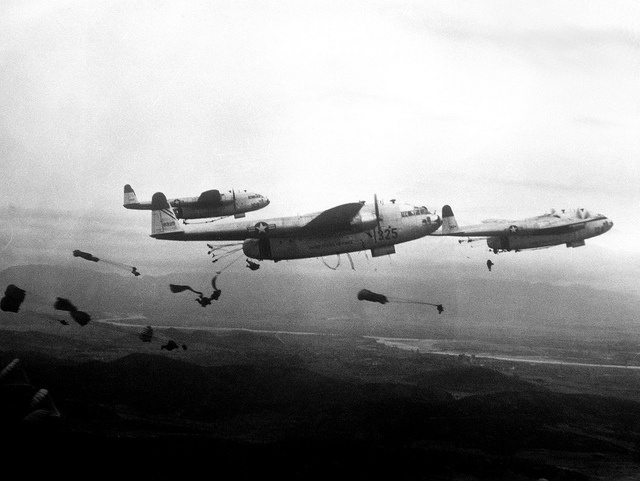Describe the objects in this image and their specific colors. I can see airplane in white, black, gray, darkgray, and lightgray tones, airplane in white, gray, lightgray, darkgray, and black tones, airplane in white, black, gray, darkgray, and lightgray tones, and people in gray, black, and white tones in this image. 